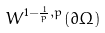<formula> <loc_0><loc_0><loc_500><loc_500>W ^ { 1 - \frac { 1 } { p } , p } ( \partial \Omega )</formula> 